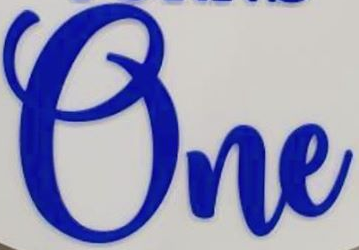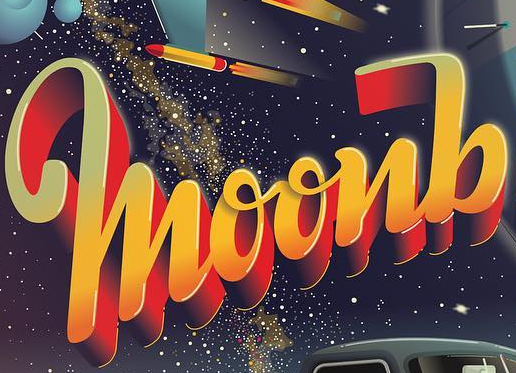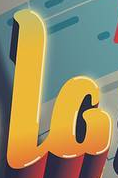What words can you see in these images in sequence, separated by a semicolon? One; moonb; la 